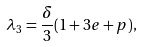Convert formula to latex. <formula><loc_0><loc_0><loc_500><loc_500>\lambda _ { 3 } = \frac { \delta } { 3 } ( 1 + 3 e + p ) ,</formula> 